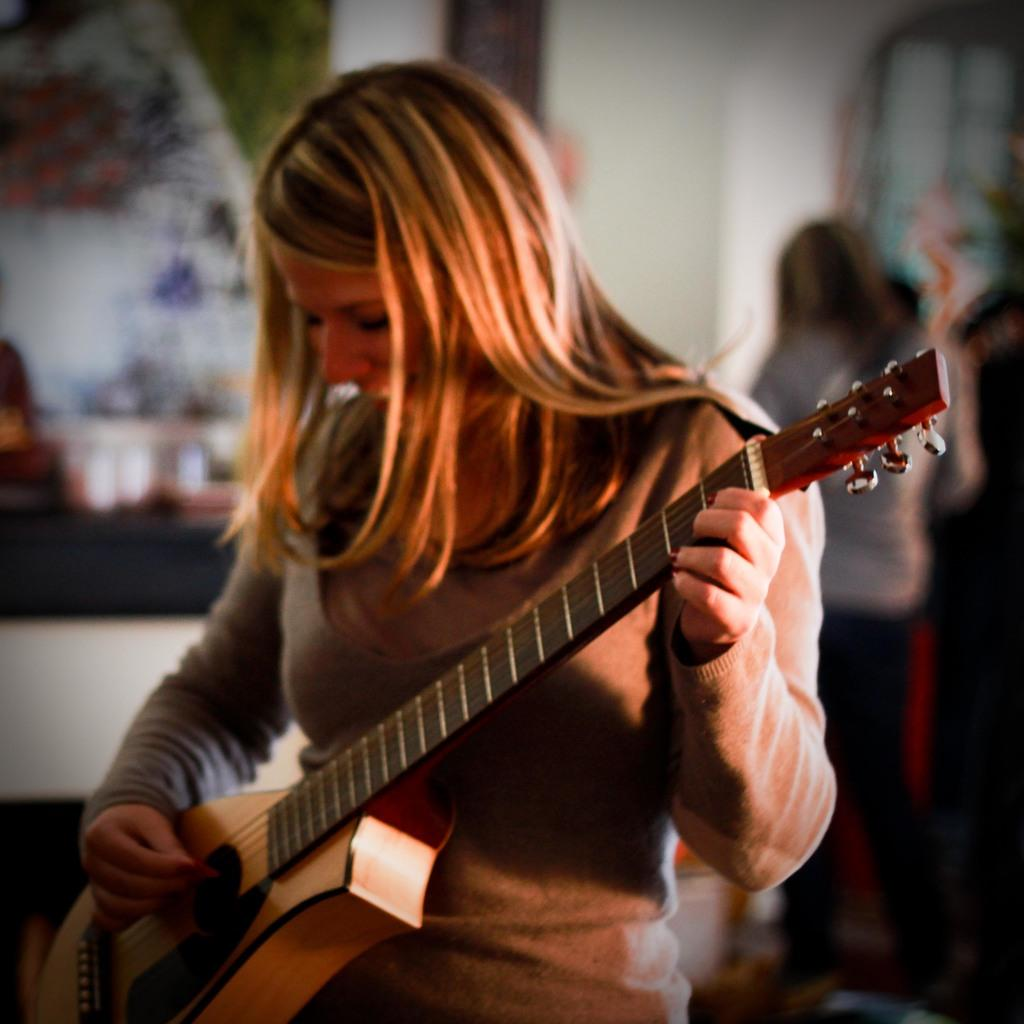What is the woman in the foreground of the image holding? The woman is holding a guitar in the image. What is the woman doing with the guitar? The woman is playing the guitar. Can you describe the background of the image? There is another woman standing in the background of the image, and there is a wall in the background as well. How many jars can be seen falling from the roof in the image? There are no jars or roof present in the image; it features a woman playing a guitar with another woman and a wall in the background. 